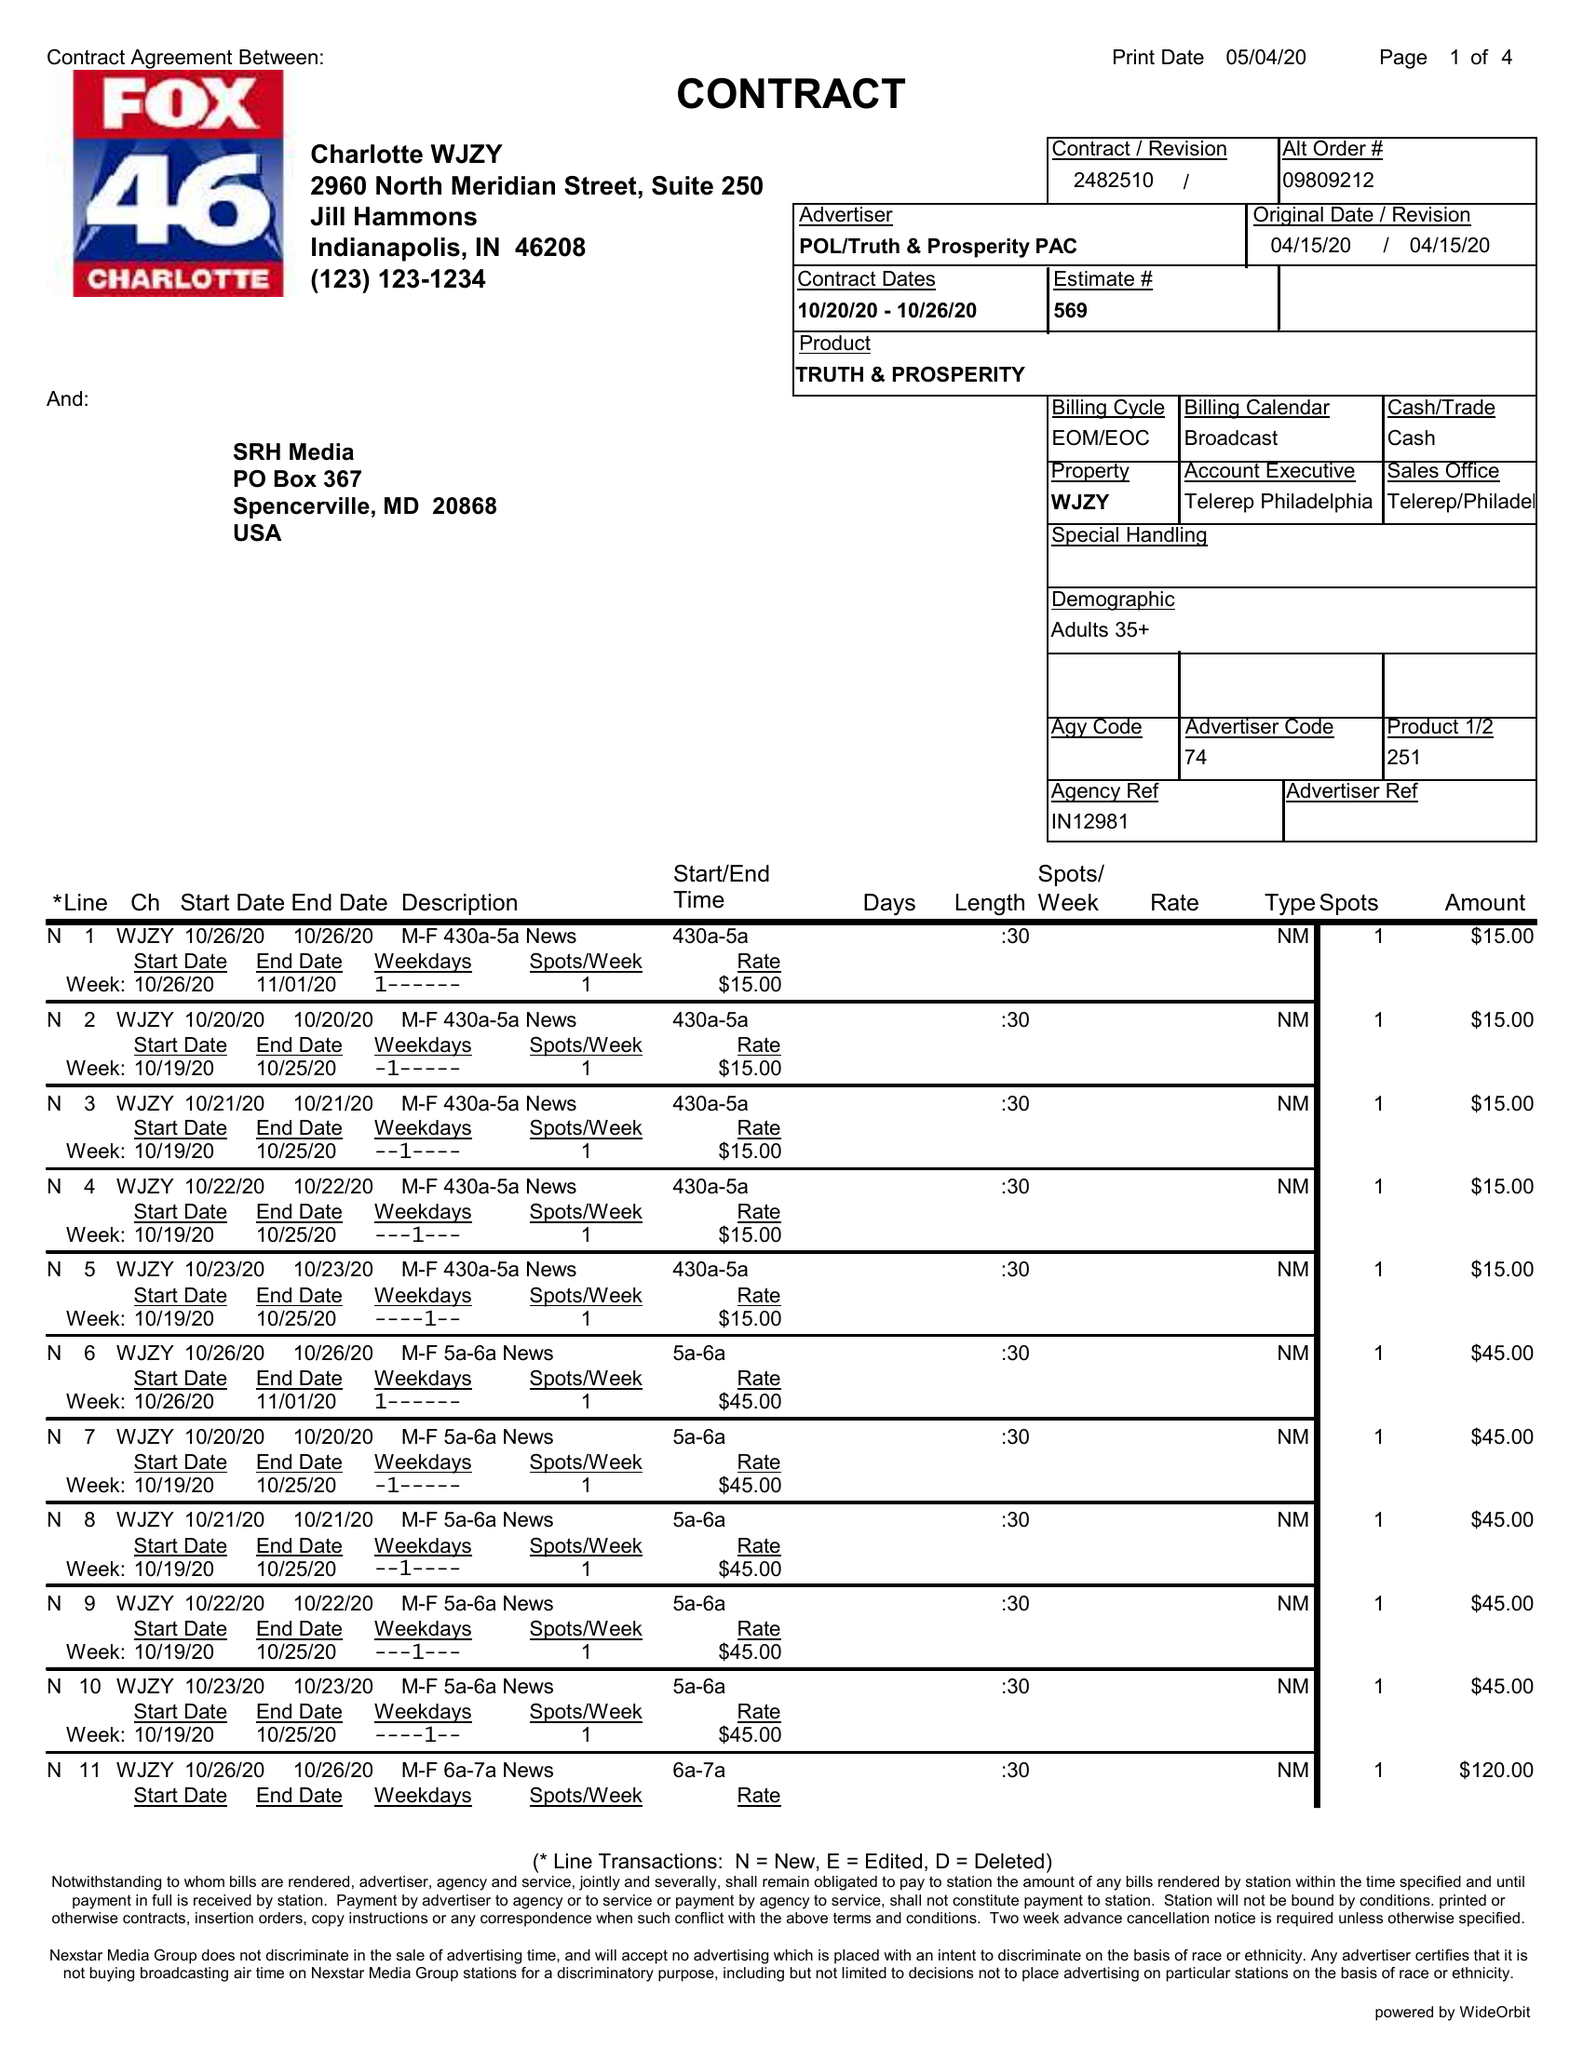What is the value for the flight_to?
Answer the question using a single word or phrase. 10/26/20 